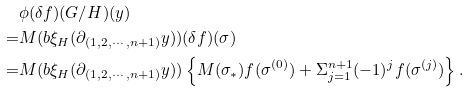<formula> <loc_0><loc_0><loc_500><loc_500>& \phi ( \delta f ) ( G / H ) ( y ) \\ = & M ( b \xi _ { H } ( \partial _ { ( 1 , 2 , \cdots , n + 1 ) } y ) ) ( \delta f ) ( \sigma ) \\ = & M ( b \xi _ { H } ( \partial _ { ( 1 , 2 , \cdots , n + 1 ) } y ) ) \left \{ M ( \sigma _ { * } ) f ( \sigma ^ { ( 0 ) } ) + \Sigma _ { j = 1 } ^ { n + 1 } ( - 1 ) ^ { j } f ( \sigma ^ { ( j ) } ) \right \} .</formula> 